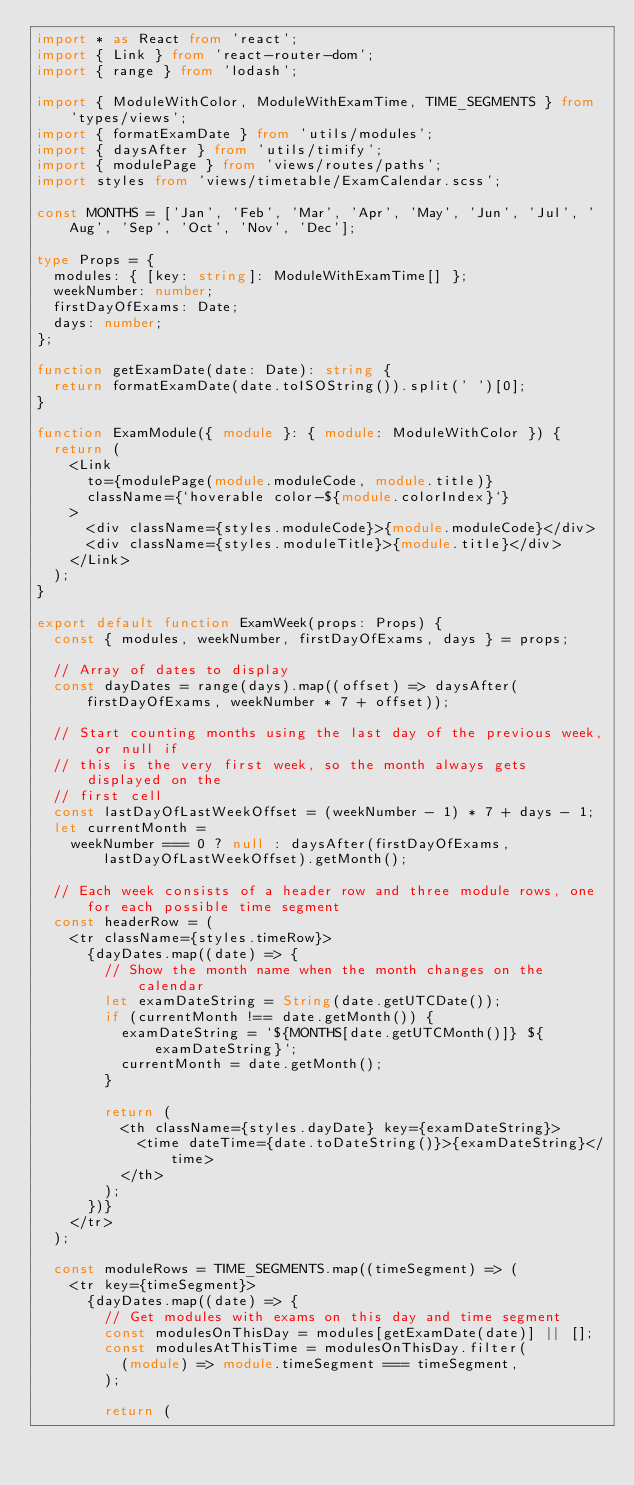<code> <loc_0><loc_0><loc_500><loc_500><_TypeScript_>import * as React from 'react';
import { Link } from 'react-router-dom';
import { range } from 'lodash';

import { ModuleWithColor, ModuleWithExamTime, TIME_SEGMENTS } from 'types/views';
import { formatExamDate } from 'utils/modules';
import { daysAfter } from 'utils/timify';
import { modulePage } from 'views/routes/paths';
import styles from 'views/timetable/ExamCalendar.scss';

const MONTHS = ['Jan', 'Feb', 'Mar', 'Apr', 'May', 'Jun', 'Jul', 'Aug', 'Sep', 'Oct', 'Nov', 'Dec'];

type Props = {
  modules: { [key: string]: ModuleWithExamTime[] };
  weekNumber: number;
  firstDayOfExams: Date;
  days: number;
};

function getExamDate(date: Date): string {
  return formatExamDate(date.toISOString()).split(' ')[0];
}

function ExamModule({ module }: { module: ModuleWithColor }) {
  return (
    <Link
      to={modulePage(module.moduleCode, module.title)}
      className={`hoverable color-${module.colorIndex}`}
    >
      <div className={styles.moduleCode}>{module.moduleCode}</div>
      <div className={styles.moduleTitle}>{module.title}</div>
    </Link>
  );
}

export default function ExamWeek(props: Props) {
  const { modules, weekNumber, firstDayOfExams, days } = props;

  // Array of dates to display
  const dayDates = range(days).map((offset) => daysAfter(firstDayOfExams, weekNumber * 7 + offset));

  // Start counting months using the last day of the previous week, or null if
  // this is the very first week, so the month always gets displayed on the
  // first cell
  const lastDayOfLastWeekOffset = (weekNumber - 1) * 7 + days - 1;
  let currentMonth =
    weekNumber === 0 ? null : daysAfter(firstDayOfExams, lastDayOfLastWeekOffset).getMonth();

  // Each week consists of a header row and three module rows, one for each possible time segment
  const headerRow = (
    <tr className={styles.timeRow}>
      {dayDates.map((date) => {
        // Show the month name when the month changes on the calendar
        let examDateString = String(date.getUTCDate());
        if (currentMonth !== date.getMonth()) {
          examDateString = `${MONTHS[date.getUTCMonth()]} ${examDateString}`;
          currentMonth = date.getMonth();
        }

        return (
          <th className={styles.dayDate} key={examDateString}>
            <time dateTime={date.toDateString()}>{examDateString}</time>
          </th>
        );
      })}
    </tr>
  );

  const moduleRows = TIME_SEGMENTS.map((timeSegment) => (
    <tr key={timeSegment}>
      {dayDates.map((date) => {
        // Get modules with exams on this day and time segment
        const modulesOnThisDay = modules[getExamDate(date)] || [];
        const modulesAtThisTime = modulesOnThisDay.filter(
          (module) => module.timeSegment === timeSegment,
        );

        return (</code> 